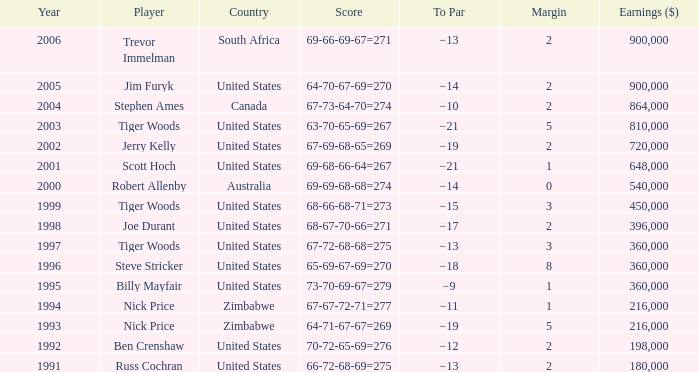In how many years has joe durant's player earned more than $396,000? 0.0. 